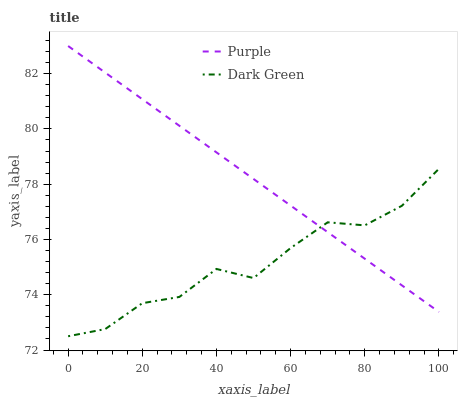Does Dark Green have the minimum area under the curve?
Answer yes or no. Yes. Does Purple have the maximum area under the curve?
Answer yes or no. Yes. Does Dark Green have the maximum area under the curve?
Answer yes or no. No. Is Purple the smoothest?
Answer yes or no. Yes. Is Dark Green the roughest?
Answer yes or no. Yes. Is Dark Green the smoothest?
Answer yes or no. No. Does Dark Green have the lowest value?
Answer yes or no. Yes. Does Purple have the highest value?
Answer yes or no. Yes. Does Dark Green have the highest value?
Answer yes or no. No. Does Dark Green intersect Purple?
Answer yes or no. Yes. Is Dark Green less than Purple?
Answer yes or no. No. Is Dark Green greater than Purple?
Answer yes or no. No. 